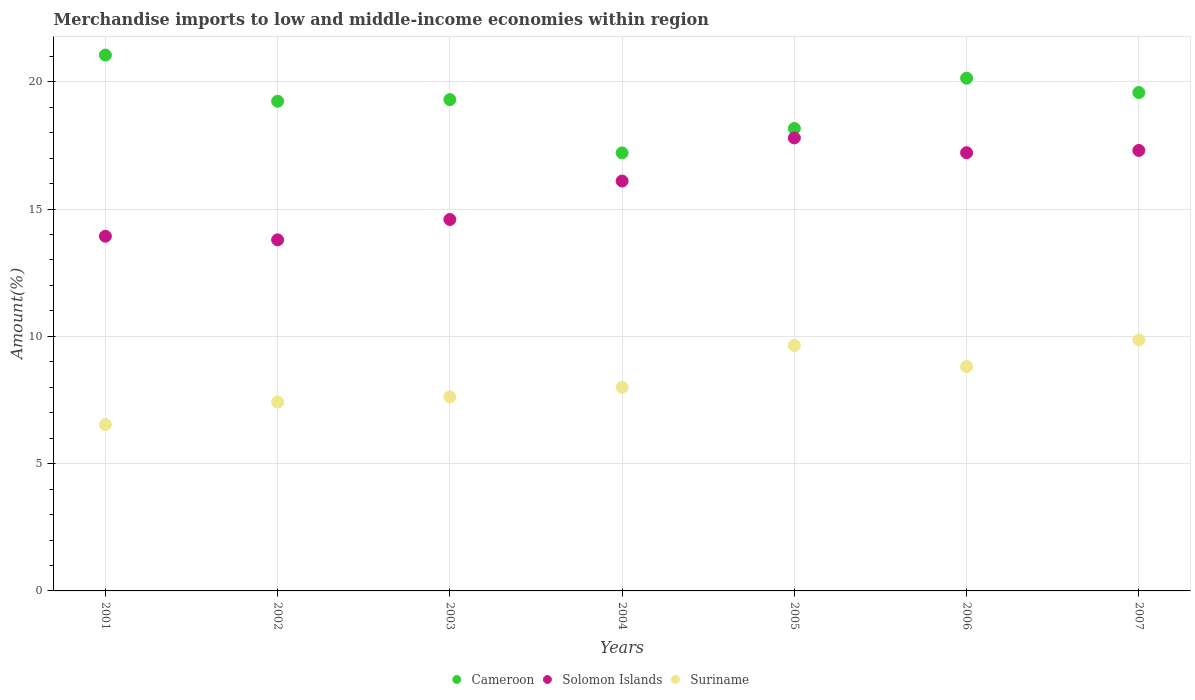How many different coloured dotlines are there?
Offer a very short reply. 3. What is the percentage of amount earned from merchandise imports in Solomon Islands in 2002?
Give a very brief answer. 13.79. Across all years, what is the maximum percentage of amount earned from merchandise imports in Suriname?
Keep it short and to the point. 9.86. Across all years, what is the minimum percentage of amount earned from merchandise imports in Suriname?
Ensure brevity in your answer.  6.53. What is the total percentage of amount earned from merchandise imports in Suriname in the graph?
Make the answer very short. 57.89. What is the difference between the percentage of amount earned from merchandise imports in Solomon Islands in 2001 and that in 2002?
Keep it short and to the point. 0.14. What is the difference between the percentage of amount earned from merchandise imports in Cameroon in 2006 and the percentage of amount earned from merchandise imports in Solomon Islands in 2005?
Provide a succinct answer. 2.35. What is the average percentage of amount earned from merchandise imports in Cameroon per year?
Ensure brevity in your answer.  19.24. In the year 2004, what is the difference between the percentage of amount earned from merchandise imports in Suriname and percentage of amount earned from merchandise imports in Solomon Islands?
Ensure brevity in your answer.  -8.1. In how many years, is the percentage of amount earned from merchandise imports in Cameroon greater than 4 %?
Your answer should be compact. 7. What is the ratio of the percentage of amount earned from merchandise imports in Solomon Islands in 2003 to that in 2007?
Give a very brief answer. 0.84. Is the difference between the percentage of amount earned from merchandise imports in Suriname in 2004 and 2005 greater than the difference between the percentage of amount earned from merchandise imports in Solomon Islands in 2004 and 2005?
Give a very brief answer. Yes. What is the difference between the highest and the second highest percentage of amount earned from merchandise imports in Suriname?
Keep it short and to the point. 0.22. What is the difference between the highest and the lowest percentage of amount earned from merchandise imports in Cameroon?
Your answer should be compact. 3.84. Is it the case that in every year, the sum of the percentage of amount earned from merchandise imports in Suriname and percentage of amount earned from merchandise imports in Solomon Islands  is greater than the percentage of amount earned from merchandise imports in Cameroon?
Keep it short and to the point. No. Is the percentage of amount earned from merchandise imports in Solomon Islands strictly less than the percentage of amount earned from merchandise imports in Cameroon over the years?
Your answer should be very brief. Yes. How many years are there in the graph?
Offer a terse response. 7. Does the graph contain grids?
Give a very brief answer. Yes. Where does the legend appear in the graph?
Keep it short and to the point. Bottom center. How many legend labels are there?
Provide a succinct answer. 3. How are the legend labels stacked?
Keep it short and to the point. Horizontal. What is the title of the graph?
Your answer should be compact. Merchandise imports to low and middle-income economies within region. Does "Cyprus" appear as one of the legend labels in the graph?
Keep it short and to the point. No. What is the label or title of the X-axis?
Make the answer very short. Years. What is the label or title of the Y-axis?
Your response must be concise. Amount(%). What is the Amount(%) of Cameroon in 2001?
Provide a short and direct response. 21.05. What is the Amount(%) in Solomon Islands in 2001?
Provide a short and direct response. 13.93. What is the Amount(%) in Suriname in 2001?
Keep it short and to the point. 6.53. What is the Amount(%) in Cameroon in 2002?
Keep it short and to the point. 19.24. What is the Amount(%) in Solomon Islands in 2002?
Your answer should be compact. 13.79. What is the Amount(%) in Suriname in 2002?
Your response must be concise. 7.42. What is the Amount(%) in Cameroon in 2003?
Offer a very short reply. 19.3. What is the Amount(%) in Solomon Islands in 2003?
Your answer should be compact. 14.59. What is the Amount(%) of Suriname in 2003?
Make the answer very short. 7.62. What is the Amount(%) in Cameroon in 2004?
Offer a terse response. 17.21. What is the Amount(%) in Solomon Islands in 2004?
Offer a very short reply. 16.1. What is the Amount(%) in Suriname in 2004?
Keep it short and to the point. 8. What is the Amount(%) of Cameroon in 2005?
Provide a short and direct response. 18.17. What is the Amount(%) of Solomon Islands in 2005?
Ensure brevity in your answer.  17.79. What is the Amount(%) of Suriname in 2005?
Make the answer very short. 9.64. What is the Amount(%) in Cameroon in 2006?
Your response must be concise. 20.14. What is the Amount(%) of Solomon Islands in 2006?
Make the answer very short. 17.21. What is the Amount(%) in Suriname in 2006?
Offer a terse response. 8.82. What is the Amount(%) of Cameroon in 2007?
Make the answer very short. 19.58. What is the Amount(%) in Solomon Islands in 2007?
Keep it short and to the point. 17.3. What is the Amount(%) of Suriname in 2007?
Your answer should be compact. 9.86. Across all years, what is the maximum Amount(%) of Cameroon?
Make the answer very short. 21.05. Across all years, what is the maximum Amount(%) of Solomon Islands?
Provide a short and direct response. 17.79. Across all years, what is the maximum Amount(%) of Suriname?
Ensure brevity in your answer.  9.86. Across all years, what is the minimum Amount(%) in Cameroon?
Ensure brevity in your answer.  17.21. Across all years, what is the minimum Amount(%) of Solomon Islands?
Make the answer very short. 13.79. Across all years, what is the minimum Amount(%) of Suriname?
Offer a terse response. 6.53. What is the total Amount(%) in Cameroon in the graph?
Give a very brief answer. 134.67. What is the total Amount(%) in Solomon Islands in the graph?
Make the answer very short. 110.73. What is the total Amount(%) of Suriname in the graph?
Provide a short and direct response. 57.89. What is the difference between the Amount(%) of Cameroon in 2001 and that in 2002?
Provide a succinct answer. 1.81. What is the difference between the Amount(%) of Solomon Islands in 2001 and that in 2002?
Your answer should be compact. 0.14. What is the difference between the Amount(%) of Suriname in 2001 and that in 2002?
Offer a terse response. -0.89. What is the difference between the Amount(%) in Cameroon in 2001 and that in 2003?
Offer a very short reply. 1.75. What is the difference between the Amount(%) of Solomon Islands in 2001 and that in 2003?
Your answer should be compact. -0.66. What is the difference between the Amount(%) in Suriname in 2001 and that in 2003?
Your answer should be very brief. -1.09. What is the difference between the Amount(%) of Cameroon in 2001 and that in 2004?
Ensure brevity in your answer.  3.84. What is the difference between the Amount(%) of Solomon Islands in 2001 and that in 2004?
Your answer should be very brief. -2.17. What is the difference between the Amount(%) of Suriname in 2001 and that in 2004?
Your answer should be very brief. -1.46. What is the difference between the Amount(%) in Cameroon in 2001 and that in 2005?
Your answer should be very brief. 2.88. What is the difference between the Amount(%) of Solomon Islands in 2001 and that in 2005?
Make the answer very short. -3.86. What is the difference between the Amount(%) in Suriname in 2001 and that in 2005?
Your answer should be compact. -3.11. What is the difference between the Amount(%) of Cameroon in 2001 and that in 2006?
Keep it short and to the point. 0.91. What is the difference between the Amount(%) in Solomon Islands in 2001 and that in 2006?
Offer a terse response. -3.28. What is the difference between the Amount(%) of Suriname in 2001 and that in 2006?
Offer a terse response. -2.28. What is the difference between the Amount(%) of Cameroon in 2001 and that in 2007?
Offer a terse response. 1.47. What is the difference between the Amount(%) in Solomon Islands in 2001 and that in 2007?
Keep it short and to the point. -3.37. What is the difference between the Amount(%) in Suriname in 2001 and that in 2007?
Keep it short and to the point. -3.33. What is the difference between the Amount(%) in Cameroon in 2002 and that in 2003?
Ensure brevity in your answer.  -0.06. What is the difference between the Amount(%) in Solomon Islands in 2002 and that in 2003?
Your response must be concise. -0.8. What is the difference between the Amount(%) of Suriname in 2002 and that in 2003?
Your answer should be compact. -0.2. What is the difference between the Amount(%) of Cameroon in 2002 and that in 2004?
Keep it short and to the point. 2.03. What is the difference between the Amount(%) of Solomon Islands in 2002 and that in 2004?
Offer a very short reply. -2.31. What is the difference between the Amount(%) of Suriname in 2002 and that in 2004?
Ensure brevity in your answer.  -0.58. What is the difference between the Amount(%) of Cameroon in 2002 and that in 2005?
Your answer should be compact. 1.07. What is the difference between the Amount(%) of Solomon Islands in 2002 and that in 2005?
Provide a succinct answer. -4. What is the difference between the Amount(%) of Suriname in 2002 and that in 2005?
Provide a short and direct response. -2.22. What is the difference between the Amount(%) in Cameroon in 2002 and that in 2006?
Offer a terse response. -0.9. What is the difference between the Amount(%) in Solomon Islands in 2002 and that in 2006?
Give a very brief answer. -3.42. What is the difference between the Amount(%) in Suriname in 2002 and that in 2006?
Ensure brevity in your answer.  -1.4. What is the difference between the Amount(%) in Cameroon in 2002 and that in 2007?
Your answer should be compact. -0.34. What is the difference between the Amount(%) of Solomon Islands in 2002 and that in 2007?
Keep it short and to the point. -3.51. What is the difference between the Amount(%) of Suriname in 2002 and that in 2007?
Ensure brevity in your answer.  -2.44. What is the difference between the Amount(%) in Cameroon in 2003 and that in 2004?
Make the answer very short. 2.09. What is the difference between the Amount(%) of Solomon Islands in 2003 and that in 2004?
Offer a very short reply. -1.51. What is the difference between the Amount(%) of Suriname in 2003 and that in 2004?
Provide a succinct answer. -0.37. What is the difference between the Amount(%) of Cameroon in 2003 and that in 2005?
Provide a succinct answer. 1.13. What is the difference between the Amount(%) of Solomon Islands in 2003 and that in 2005?
Provide a succinct answer. -3.2. What is the difference between the Amount(%) of Suriname in 2003 and that in 2005?
Your answer should be compact. -2.02. What is the difference between the Amount(%) in Cameroon in 2003 and that in 2006?
Provide a succinct answer. -0.84. What is the difference between the Amount(%) of Solomon Islands in 2003 and that in 2006?
Give a very brief answer. -2.62. What is the difference between the Amount(%) of Suriname in 2003 and that in 2006?
Provide a short and direct response. -1.19. What is the difference between the Amount(%) in Cameroon in 2003 and that in 2007?
Your answer should be compact. -0.28. What is the difference between the Amount(%) of Solomon Islands in 2003 and that in 2007?
Your answer should be very brief. -2.71. What is the difference between the Amount(%) of Suriname in 2003 and that in 2007?
Offer a terse response. -2.23. What is the difference between the Amount(%) in Cameroon in 2004 and that in 2005?
Your response must be concise. -0.96. What is the difference between the Amount(%) of Solomon Islands in 2004 and that in 2005?
Ensure brevity in your answer.  -1.69. What is the difference between the Amount(%) in Suriname in 2004 and that in 2005?
Your answer should be very brief. -1.64. What is the difference between the Amount(%) in Cameroon in 2004 and that in 2006?
Your answer should be compact. -2.94. What is the difference between the Amount(%) in Solomon Islands in 2004 and that in 2006?
Keep it short and to the point. -1.11. What is the difference between the Amount(%) in Suriname in 2004 and that in 2006?
Your response must be concise. -0.82. What is the difference between the Amount(%) of Cameroon in 2004 and that in 2007?
Offer a terse response. -2.37. What is the difference between the Amount(%) of Solomon Islands in 2004 and that in 2007?
Provide a succinct answer. -1.2. What is the difference between the Amount(%) in Suriname in 2004 and that in 2007?
Offer a terse response. -1.86. What is the difference between the Amount(%) of Cameroon in 2005 and that in 2006?
Your answer should be very brief. -1.98. What is the difference between the Amount(%) in Solomon Islands in 2005 and that in 2006?
Offer a very short reply. 0.58. What is the difference between the Amount(%) of Suriname in 2005 and that in 2006?
Offer a terse response. 0.83. What is the difference between the Amount(%) in Cameroon in 2005 and that in 2007?
Your answer should be compact. -1.41. What is the difference between the Amount(%) of Solomon Islands in 2005 and that in 2007?
Provide a short and direct response. 0.49. What is the difference between the Amount(%) in Suriname in 2005 and that in 2007?
Make the answer very short. -0.22. What is the difference between the Amount(%) in Cameroon in 2006 and that in 2007?
Give a very brief answer. 0.56. What is the difference between the Amount(%) in Solomon Islands in 2006 and that in 2007?
Provide a short and direct response. -0.09. What is the difference between the Amount(%) of Suriname in 2006 and that in 2007?
Your answer should be compact. -1.04. What is the difference between the Amount(%) of Cameroon in 2001 and the Amount(%) of Solomon Islands in 2002?
Offer a very short reply. 7.26. What is the difference between the Amount(%) of Cameroon in 2001 and the Amount(%) of Suriname in 2002?
Your response must be concise. 13.63. What is the difference between the Amount(%) in Solomon Islands in 2001 and the Amount(%) in Suriname in 2002?
Give a very brief answer. 6.51. What is the difference between the Amount(%) in Cameroon in 2001 and the Amount(%) in Solomon Islands in 2003?
Provide a short and direct response. 6.46. What is the difference between the Amount(%) of Cameroon in 2001 and the Amount(%) of Suriname in 2003?
Your answer should be very brief. 13.43. What is the difference between the Amount(%) of Solomon Islands in 2001 and the Amount(%) of Suriname in 2003?
Make the answer very short. 6.31. What is the difference between the Amount(%) in Cameroon in 2001 and the Amount(%) in Solomon Islands in 2004?
Your answer should be very brief. 4.95. What is the difference between the Amount(%) of Cameroon in 2001 and the Amount(%) of Suriname in 2004?
Your answer should be very brief. 13.05. What is the difference between the Amount(%) of Solomon Islands in 2001 and the Amount(%) of Suriname in 2004?
Offer a terse response. 5.94. What is the difference between the Amount(%) of Cameroon in 2001 and the Amount(%) of Solomon Islands in 2005?
Make the answer very short. 3.26. What is the difference between the Amount(%) in Cameroon in 2001 and the Amount(%) in Suriname in 2005?
Provide a short and direct response. 11.41. What is the difference between the Amount(%) in Solomon Islands in 2001 and the Amount(%) in Suriname in 2005?
Your answer should be compact. 4.29. What is the difference between the Amount(%) of Cameroon in 2001 and the Amount(%) of Solomon Islands in 2006?
Offer a terse response. 3.84. What is the difference between the Amount(%) of Cameroon in 2001 and the Amount(%) of Suriname in 2006?
Offer a very short reply. 12.23. What is the difference between the Amount(%) in Solomon Islands in 2001 and the Amount(%) in Suriname in 2006?
Offer a very short reply. 5.12. What is the difference between the Amount(%) in Cameroon in 2001 and the Amount(%) in Solomon Islands in 2007?
Your answer should be compact. 3.75. What is the difference between the Amount(%) in Cameroon in 2001 and the Amount(%) in Suriname in 2007?
Offer a very short reply. 11.19. What is the difference between the Amount(%) of Solomon Islands in 2001 and the Amount(%) of Suriname in 2007?
Your response must be concise. 4.07. What is the difference between the Amount(%) of Cameroon in 2002 and the Amount(%) of Solomon Islands in 2003?
Make the answer very short. 4.65. What is the difference between the Amount(%) of Cameroon in 2002 and the Amount(%) of Suriname in 2003?
Ensure brevity in your answer.  11.61. What is the difference between the Amount(%) in Solomon Islands in 2002 and the Amount(%) in Suriname in 2003?
Provide a succinct answer. 6.17. What is the difference between the Amount(%) of Cameroon in 2002 and the Amount(%) of Solomon Islands in 2004?
Your response must be concise. 3.14. What is the difference between the Amount(%) of Cameroon in 2002 and the Amount(%) of Suriname in 2004?
Provide a short and direct response. 11.24. What is the difference between the Amount(%) of Solomon Islands in 2002 and the Amount(%) of Suriname in 2004?
Provide a short and direct response. 5.79. What is the difference between the Amount(%) in Cameroon in 2002 and the Amount(%) in Solomon Islands in 2005?
Ensure brevity in your answer.  1.44. What is the difference between the Amount(%) of Cameroon in 2002 and the Amount(%) of Suriname in 2005?
Your response must be concise. 9.6. What is the difference between the Amount(%) of Solomon Islands in 2002 and the Amount(%) of Suriname in 2005?
Your answer should be very brief. 4.15. What is the difference between the Amount(%) in Cameroon in 2002 and the Amount(%) in Solomon Islands in 2006?
Your answer should be compact. 2.02. What is the difference between the Amount(%) of Cameroon in 2002 and the Amount(%) of Suriname in 2006?
Offer a very short reply. 10.42. What is the difference between the Amount(%) of Solomon Islands in 2002 and the Amount(%) of Suriname in 2006?
Give a very brief answer. 4.97. What is the difference between the Amount(%) of Cameroon in 2002 and the Amount(%) of Solomon Islands in 2007?
Ensure brevity in your answer.  1.93. What is the difference between the Amount(%) in Cameroon in 2002 and the Amount(%) in Suriname in 2007?
Offer a terse response. 9.38. What is the difference between the Amount(%) in Solomon Islands in 2002 and the Amount(%) in Suriname in 2007?
Make the answer very short. 3.93. What is the difference between the Amount(%) of Cameroon in 2003 and the Amount(%) of Solomon Islands in 2004?
Your answer should be very brief. 3.2. What is the difference between the Amount(%) in Cameroon in 2003 and the Amount(%) in Suriname in 2004?
Keep it short and to the point. 11.3. What is the difference between the Amount(%) in Solomon Islands in 2003 and the Amount(%) in Suriname in 2004?
Keep it short and to the point. 6.59. What is the difference between the Amount(%) of Cameroon in 2003 and the Amount(%) of Solomon Islands in 2005?
Provide a succinct answer. 1.5. What is the difference between the Amount(%) in Cameroon in 2003 and the Amount(%) in Suriname in 2005?
Your answer should be very brief. 9.66. What is the difference between the Amount(%) in Solomon Islands in 2003 and the Amount(%) in Suriname in 2005?
Your answer should be compact. 4.95. What is the difference between the Amount(%) in Cameroon in 2003 and the Amount(%) in Solomon Islands in 2006?
Keep it short and to the point. 2.09. What is the difference between the Amount(%) in Cameroon in 2003 and the Amount(%) in Suriname in 2006?
Give a very brief answer. 10.48. What is the difference between the Amount(%) of Solomon Islands in 2003 and the Amount(%) of Suriname in 2006?
Make the answer very short. 5.78. What is the difference between the Amount(%) in Cameroon in 2003 and the Amount(%) in Solomon Islands in 2007?
Your response must be concise. 2. What is the difference between the Amount(%) of Cameroon in 2003 and the Amount(%) of Suriname in 2007?
Provide a short and direct response. 9.44. What is the difference between the Amount(%) in Solomon Islands in 2003 and the Amount(%) in Suriname in 2007?
Provide a succinct answer. 4.73. What is the difference between the Amount(%) in Cameroon in 2004 and the Amount(%) in Solomon Islands in 2005?
Your answer should be compact. -0.59. What is the difference between the Amount(%) of Cameroon in 2004 and the Amount(%) of Suriname in 2005?
Your answer should be very brief. 7.56. What is the difference between the Amount(%) of Solomon Islands in 2004 and the Amount(%) of Suriname in 2005?
Provide a succinct answer. 6.46. What is the difference between the Amount(%) in Cameroon in 2004 and the Amount(%) in Solomon Islands in 2006?
Provide a short and direct response. -0.01. What is the difference between the Amount(%) of Cameroon in 2004 and the Amount(%) of Suriname in 2006?
Offer a terse response. 8.39. What is the difference between the Amount(%) of Solomon Islands in 2004 and the Amount(%) of Suriname in 2006?
Provide a succinct answer. 7.29. What is the difference between the Amount(%) in Cameroon in 2004 and the Amount(%) in Solomon Islands in 2007?
Provide a succinct answer. -0.1. What is the difference between the Amount(%) of Cameroon in 2004 and the Amount(%) of Suriname in 2007?
Your response must be concise. 7.35. What is the difference between the Amount(%) in Solomon Islands in 2004 and the Amount(%) in Suriname in 2007?
Ensure brevity in your answer.  6.24. What is the difference between the Amount(%) of Cameroon in 2005 and the Amount(%) of Solomon Islands in 2006?
Provide a short and direct response. 0.95. What is the difference between the Amount(%) in Cameroon in 2005 and the Amount(%) in Suriname in 2006?
Give a very brief answer. 9.35. What is the difference between the Amount(%) in Solomon Islands in 2005 and the Amount(%) in Suriname in 2006?
Provide a succinct answer. 8.98. What is the difference between the Amount(%) of Cameroon in 2005 and the Amount(%) of Solomon Islands in 2007?
Provide a short and direct response. 0.86. What is the difference between the Amount(%) in Cameroon in 2005 and the Amount(%) in Suriname in 2007?
Provide a succinct answer. 8.31. What is the difference between the Amount(%) of Solomon Islands in 2005 and the Amount(%) of Suriname in 2007?
Provide a succinct answer. 7.94. What is the difference between the Amount(%) of Cameroon in 2006 and the Amount(%) of Solomon Islands in 2007?
Your response must be concise. 2.84. What is the difference between the Amount(%) of Cameroon in 2006 and the Amount(%) of Suriname in 2007?
Provide a succinct answer. 10.28. What is the difference between the Amount(%) of Solomon Islands in 2006 and the Amount(%) of Suriname in 2007?
Offer a terse response. 7.35. What is the average Amount(%) of Cameroon per year?
Your answer should be compact. 19.24. What is the average Amount(%) of Solomon Islands per year?
Provide a succinct answer. 15.82. What is the average Amount(%) in Suriname per year?
Your response must be concise. 8.27. In the year 2001, what is the difference between the Amount(%) in Cameroon and Amount(%) in Solomon Islands?
Keep it short and to the point. 7.12. In the year 2001, what is the difference between the Amount(%) of Cameroon and Amount(%) of Suriname?
Offer a very short reply. 14.52. In the year 2002, what is the difference between the Amount(%) in Cameroon and Amount(%) in Solomon Islands?
Ensure brevity in your answer.  5.45. In the year 2002, what is the difference between the Amount(%) of Cameroon and Amount(%) of Suriname?
Offer a terse response. 11.82. In the year 2002, what is the difference between the Amount(%) of Solomon Islands and Amount(%) of Suriname?
Ensure brevity in your answer.  6.37. In the year 2003, what is the difference between the Amount(%) of Cameroon and Amount(%) of Solomon Islands?
Keep it short and to the point. 4.71. In the year 2003, what is the difference between the Amount(%) of Cameroon and Amount(%) of Suriname?
Your answer should be compact. 11.68. In the year 2003, what is the difference between the Amount(%) of Solomon Islands and Amount(%) of Suriname?
Offer a terse response. 6.97. In the year 2004, what is the difference between the Amount(%) of Cameroon and Amount(%) of Solomon Islands?
Make the answer very short. 1.1. In the year 2004, what is the difference between the Amount(%) in Cameroon and Amount(%) in Suriname?
Offer a very short reply. 9.21. In the year 2004, what is the difference between the Amount(%) of Solomon Islands and Amount(%) of Suriname?
Provide a short and direct response. 8.1. In the year 2005, what is the difference between the Amount(%) in Cameroon and Amount(%) in Solomon Islands?
Your response must be concise. 0.37. In the year 2005, what is the difference between the Amount(%) in Cameroon and Amount(%) in Suriname?
Offer a very short reply. 8.52. In the year 2005, what is the difference between the Amount(%) in Solomon Islands and Amount(%) in Suriname?
Provide a short and direct response. 8.15. In the year 2006, what is the difference between the Amount(%) of Cameroon and Amount(%) of Solomon Islands?
Your answer should be very brief. 2.93. In the year 2006, what is the difference between the Amount(%) in Cameroon and Amount(%) in Suriname?
Keep it short and to the point. 11.33. In the year 2006, what is the difference between the Amount(%) in Solomon Islands and Amount(%) in Suriname?
Give a very brief answer. 8.4. In the year 2007, what is the difference between the Amount(%) in Cameroon and Amount(%) in Solomon Islands?
Give a very brief answer. 2.27. In the year 2007, what is the difference between the Amount(%) in Cameroon and Amount(%) in Suriname?
Offer a terse response. 9.72. In the year 2007, what is the difference between the Amount(%) in Solomon Islands and Amount(%) in Suriname?
Offer a terse response. 7.44. What is the ratio of the Amount(%) in Cameroon in 2001 to that in 2002?
Your answer should be very brief. 1.09. What is the ratio of the Amount(%) in Solomon Islands in 2001 to that in 2002?
Ensure brevity in your answer.  1.01. What is the ratio of the Amount(%) of Suriname in 2001 to that in 2002?
Provide a short and direct response. 0.88. What is the ratio of the Amount(%) of Cameroon in 2001 to that in 2003?
Offer a terse response. 1.09. What is the ratio of the Amount(%) in Solomon Islands in 2001 to that in 2003?
Provide a short and direct response. 0.95. What is the ratio of the Amount(%) of Suriname in 2001 to that in 2003?
Your answer should be compact. 0.86. What is the ratio of the Amount(%) in Cameroon in 2001 to that in 2004?
Offer a very short reply. 1.22. What is the ratio of the Amount(%) in Solomon Islands in 2001 to that in 2004?
Keep it short and to the point. 0.87. What is the ratio of the Amount(%) of Suriname in 2001 to that in 2004?
Provide a short and direct response. 0.82. What is the ratio of the Amount(%) in Cameroon in 2001 to that in 2005?
Give a very brief answer. 1.16. What is the ratio of the Amount(%) of Solomon Islands in 2001 to that in 2005?
Keep it short and to the point. 0.78. What is the ratio of the Amount(%) in Suriname in 2001 to that in 2005?
Provide a short and direct response. 0.68. What is the ratio of the Amount(%) of Cameroon in 2001 to that in 2006?
Give a very brief answer. 1.05. What is the ratio of the Amount(%) in Solomon Islands in 2001 to that in 2006?
Your response must be concise. 0.81. What is the ratio of the Amount(%) of Suriname in 2001 to that in 2006?
Provide a succinct answer. 0.74. What is the ratio of the Amount(%) in Cameroon in 2001 to that in 2007?
Make the answer very short. 1.08. What is the ratio of the Amount(%) of Solomon Islands in 2001 to that in 2007?
Give a very brief answer. 0.81. What is the ratio of the Amount(%) in Suriname in 2001 to that in 2007?
Your answer should be compact. 0.66. What is the ratio of the Amount(%) of Cameroon in 2002 to that in 2003?
Offer a terse response. 1. What is the ratio of the Amount(%) in Solomon Islands in 2002 to that in 2003?
Your response must be concise. 0.95. What is the ratio of the Amount(%) of Suriname in 2002 to that in 2003?
Give a very brief answer. 0.97. What is the ratio of the Amount(%) of Cameroon in 2002 to that in 2004?
Your response must be concise. 1.12. What is the ratio of the Amount(%) of Solomon Islands in 2002 to that in 2004?
Your response must be concise. 0.86. What is the ratio of the Amount(%) in Suriname in 2002 to that in 2004?
Offer a very short reply. 0.93. What is the ratio of the Amount(%) in Cameroon in 2002 to that in 2005?
Ensure brevity in your answer.  1.06. What is the ratio of the Amount(%) of Solomon Islands in 2002 to that in 2005?
Ensure brevity in your answer.  0.78. What is the ratio of the Amount(%) in Suriname in 2002 to that in 2005?
Your answer should be very brief. 0.77. What is the ratio of the Amount(%) of Cameroon in 2002 to that in 2006?
Make the answer very short. 0.96. What is the ratio of the Amount(%) of Solomon Islands in 2002 to that in 2006?
Provide a succinct answer. 0.8. What is the ratio of the Amount(%) of Suriname in 2002 to that in 2006?
Keep it short and to the point. 0.84. What is the ratio of the Amount(%) in Cameroon in 2002 to that in 2007?
Offer a terse response. 0.98. What is the ratio of the Amount(%) in Solomon Islands in 2002 to that in 2007?
Offer a terse response. 0.8. What is the ratio of the Amount(%) in Suriname in 2002 to that in 2007?
Provide a short and direct response. 0.75. What is the ratio of the Amount(%) of Cameroon in 2003 to that in 2004?
Your answer should be very brief. 1.12. What is the ratio of the Amount(%) in Solomon Islands in 2003 to that in 2004?
Give a very brief answer. 0.91. What is the ratio of the Amount(%) in Suriname in 2003 to that in 2004?
Keep it short and to the point. 0.95. What is the ratio of the Amount(%) of Cameroon in 2003 to that in 2005?
Offer a terse response. 1.06. What is the ratio of the Amount(%) in Solomon Islands in 2003 to that in 2005?
Your answer should be very brief. 0.82. What is the ratio of the Amount(%) of Suriname in 2003 to that in 2005?
Keep it short and to the point. 0.79. What is the ratio of the Amount(%) in Cameroon in 2003 to that in 2006?
Provide a succinct answer. 0.96. What is the ratio of the Amount(%) in Solomon Islands in 2003 to that in 2006?
Your response must be concise. 0.85. What is the ratio of the Amount(%) of Suriname in 2003 to that in 2006?
Make the answer very short. 0.86. What is the ratio of the Amount(%) in Cameroon in 2003 to that in 2007?
Provide a succinct answer. 0.99. What is the ratio of the Amount(%) of Solomon Islands in 2003 to that in 2007?
Give a very brief answer. 0.84. What is the ratio of the Amount(%) of Suriname in 2003 to that in 2007?
Provide a succinct answer. 0.77. What is the ratio of the Amount(%) in Cameroon in 2004 to that in 2005?
Keep it short and to the point. 0.95. What is the ratio of the Amount(%) of Solomon Islands in 2004 to that in 2005?
Offer a terse response. 0.9. What is the ratio of the Amount(%) of Suriname in 2004 to that in 2005?
Make the answer very short. 0.83. What is the ratio of the Amount(%) in Cameroon in 2004 to that in 2006?
Your answer should be compact. 0.85. What is the ratio of the Amount(%) in Solomon Islands in 2004 to that in 2006?
Your answer should be very brief. 0.94. What is the ratio of the Amount(%) of Suriname in 2004 to that in 2006?
Your response must be concise. 0.91. What is the ratio of the Amount(%) of Cameroon in 2004 to that in 2007?
Your answer should be compact. 0.88. What is the ratio of the Amount(%) in Solomon Islands in 2004 to that in 2007?
Offer a very short reply. 0.93. What is the ratio of the Amount(%) in Suriname in 2004 to that in 2007?
Your answer should be very brief. 0.81. What is the ratio of the Amount(%) in Cameroon in 2005 to that in 2006?
Provide a short and direct response. 0.9. What is the ratio of the Amount(%) of Solomon Islands in 2005 to that in 2006?
Make the answer very short. 1.03. What is the ratio of the Amount(%) of Suriname in 2005 to that in 2006?
Your response must be concise. 1.09. What is the ratio of the Amount(%) in Cameroon in 2005 to that in 2007?
Provide a short and direct response. 0.93. What is the ratio of the Amount(%) of Solomon Islands in 2005 to that in 2007?
Your response must be concise. 1.03. What is the ratio of the Amount(%) of Cameroon in 2006 to that in 2007?
Provide a succinct answer. 1.03. What is the ratio of the Amount(%) of Suriname in 2006 to that in 2007?
Keep it short and to the point. 0.89. What is the difference between the highest and the second highest Amount(%) of Cameroon?
Make the answer very short. 0.91. What is the difference between the highest and the second highest Amount(%) of Solomon Islands?
Your answer should be compact. 0.49. What is the difference between the highest and the second highest Amount(%) in Suriname?
Provide a short and direct response. 0.22. What is the difference between the highest and the lowest Amount(%) of Cameroon?
Keep it short and to the point. 3.84. What is the difference between the highest and the lowest Amount(%) in Solomon Islands?
Keep it short and to the point. 4. What is the difference between the highest and the lowest Amount(%) in Suriname?
Your answer should be very brief. 3.33. 